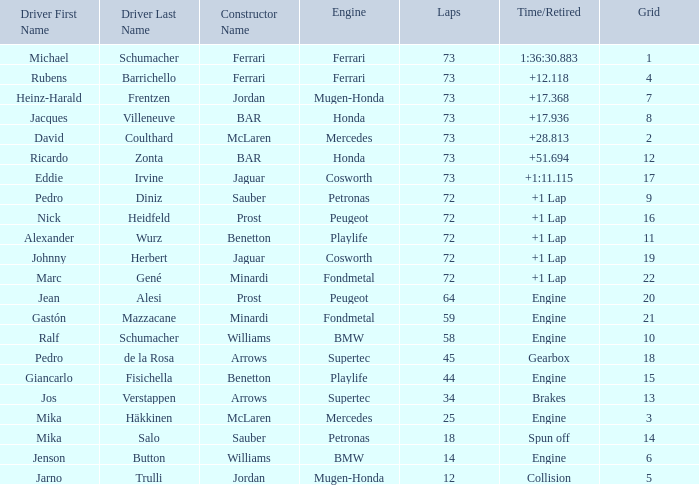How many laps did Giancarlo Fisichella do with a grid larger than 15? 0.0. 